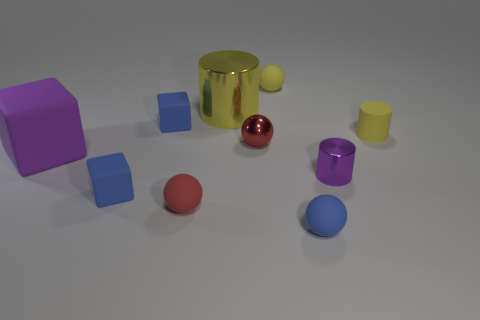There is another big cylinder that is the same color as the rubber cylinder; what is it made of?
Keep it short and to the point. Metal. What is the material of the tiny blue object that is on the right side of the red thing behind the cylinder in front of the large matte object?
Keep it short and to the point. Rubber. There is a shiny cylinder that is on the left side of the small yellow matte sphere; is it the same color as the small rubber cylinder?
Your answer should be very brief. Yes. The ball that is in front of the large purple cube and right of the tiny red rubber object is made of what material?
Make the answer very short. Rubber. Is there a yellow object of the same size as the rubber cylinder?
Keep it short and to the point. Yes. What number of big shiny things are there?
Ensure brevity in your answer.  1. There is a tiny purple shiny cylinder; how many small metallic cylinders are behind it?
Provide a short and direct response. 0. Do the big purple block and the large yellow object have the same material?
Your answer should be very brief. No. How many tiny matte objects are in front of the purple block and on the right side of the small red metal object?
Your response must be concise. 1. What number of other things are the same color as the big matte cube?
Offer a terse response. 1. 